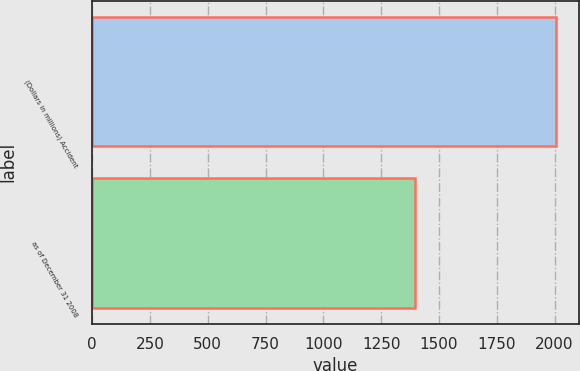<chart> <loc_0><loc_0><loc_500><loc_500><bar_chart><fcel>(Dollars in millions) Accident<fcel>as of December 31 2008<nl><fcel>2006<fcel>1397<nl></chart> 